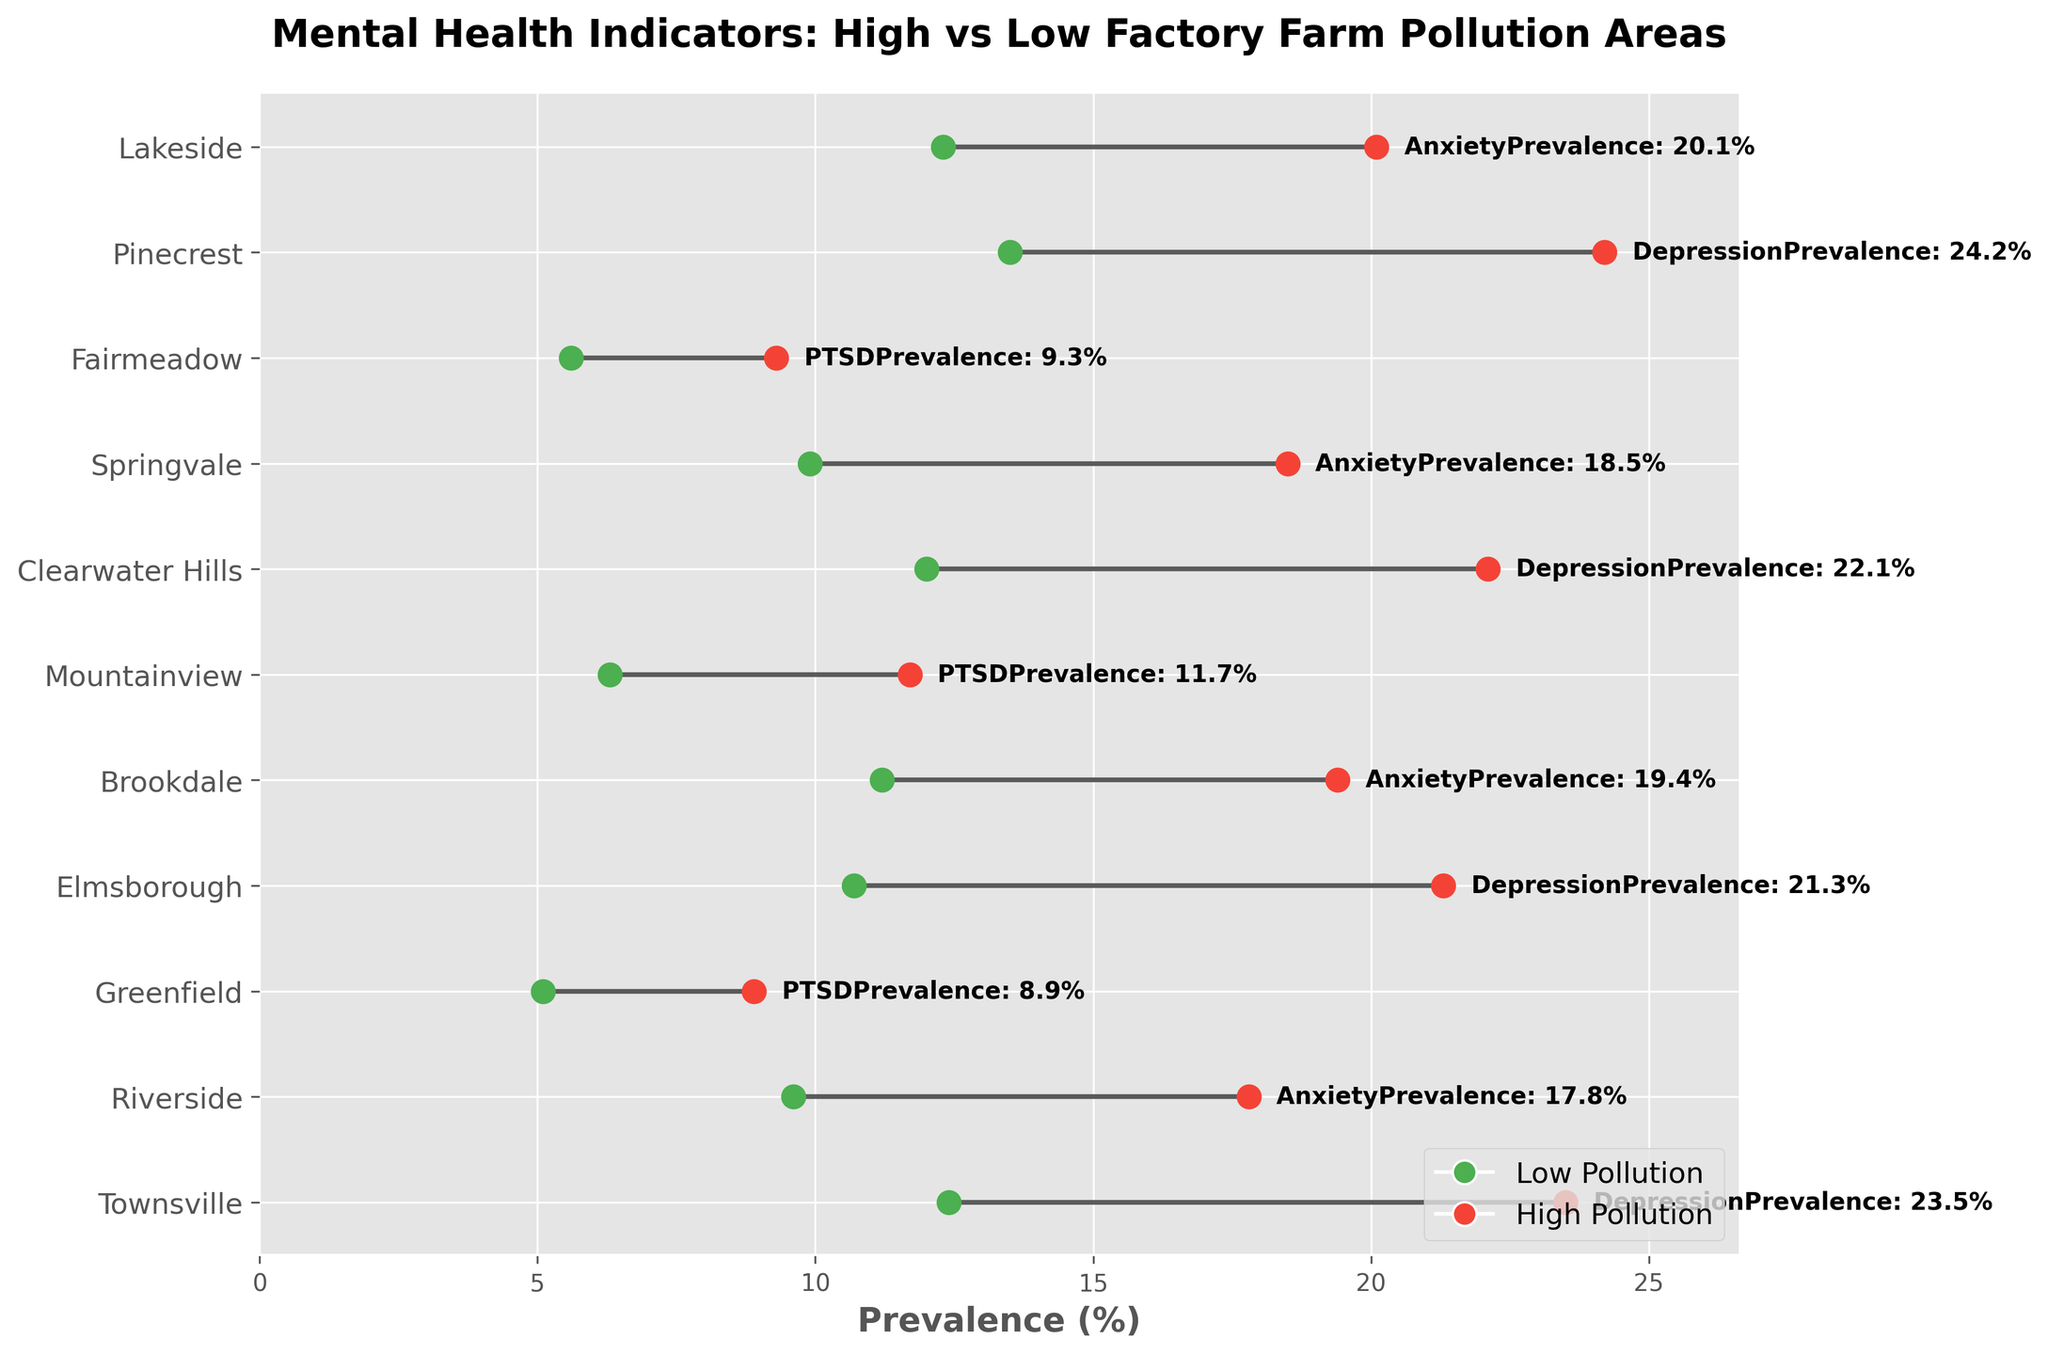What is the title of the plot? The title of the plot is located at the top and describes the overall comparison being made. It reads: "Mental Health Indicators: High vs Low Factory Farm Pollution Areas".
Answer: Mental Health Indicators: High vs Low Factory Farm Pollution Areas What are the colors used to represent low pollution and high pollution? The colors used in the plot to represent different pollution levels can be identified directly from the legend. Low pollution is represented by green, and high pollution is represented by red.
Answer: Green for low pollution, red for high pollution How many locations are compared in the plot? By counting the number of y-ticks or labels along the y-axis, which represent different locations, we can determine that there are 11 locations compared in the plot.
Answer: 11 Which location has the highest prevalence of depression in high pollution areas? By examining the red dots that represent high pollution levels and the associated prevalence percentages for depression, we see that Pinecrest has the highest prevalence at 24.2%.
Answer: Pinecrest What's the difference in anxiety prevalence between high and low pollution areas in Brookdale? The plot shows that the anxiety prevalence in Brookdale is 19.4% for high pollution and 11.2% for low pollution. The difference is 19.4 - 11.2.
Answer: 8.2% Which mental health indicator shows the smallest difference between high and low pollution areas in any location? Reviewing the differences between high and low pollution values for each mental health indicator at all locations, Greenfield (PTSDPrevalence) shows the smallest difference, 8.9% - 5.1%.
Answer: PTSD in Greenfield, 3.8% In which location is the mental health indicator least affected by pollution? Considering the smallest differences between high and low pollution levels across all locations, PTSD in Greenfield has the smallest impact with a difference of 3.8%.
Answer: Greenfield Which mental health indicator in Fairmeadow changes the most between high and low pollution areas? By comparing the indicators for Fairmeadow, we see the PTSD prevalence changes from 9.3% in high pollution to 5.6% in low pollution. The change is 9.3 - 5.6.
Answer: PTSD, 3.7% What is the average prevalence of PTSD in high pollution areas across all locations? Summing up the PTSD prevalence percentages in high pollution areas and dividing by the number of data points (3), we get (8.9 + 11.7 + 9.3) / 3.
Answer: 9.97% Which location has the largest gap in depression prevalence between high and low pollution areas? Examining the differences where depression prevalence is provided, the largest gap is at Pinecrest with high (24.2%) and low (13.5%) pollution, resulting in a gap of 24.2 - 13.5.
Answer: Pinecrest, 10.7% 